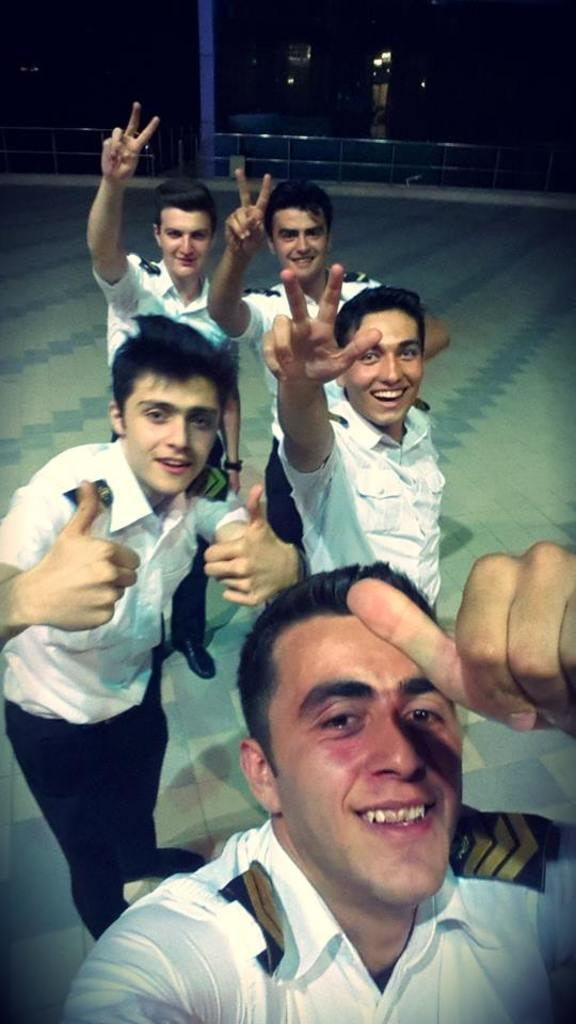How many people are in the image? There are people in the image, but the exact number is not specified. What are the people doing in the image? The people are standing and smiling in the image. What can be seen in the background of the image? There are lights and other objects visible in the background of the image. Can you see a pet swimming in the lake in the image? There is no lake or pet present in the image. What type of body is visible in the image? The image does not depict any bodies; it features people standing and smiling. 